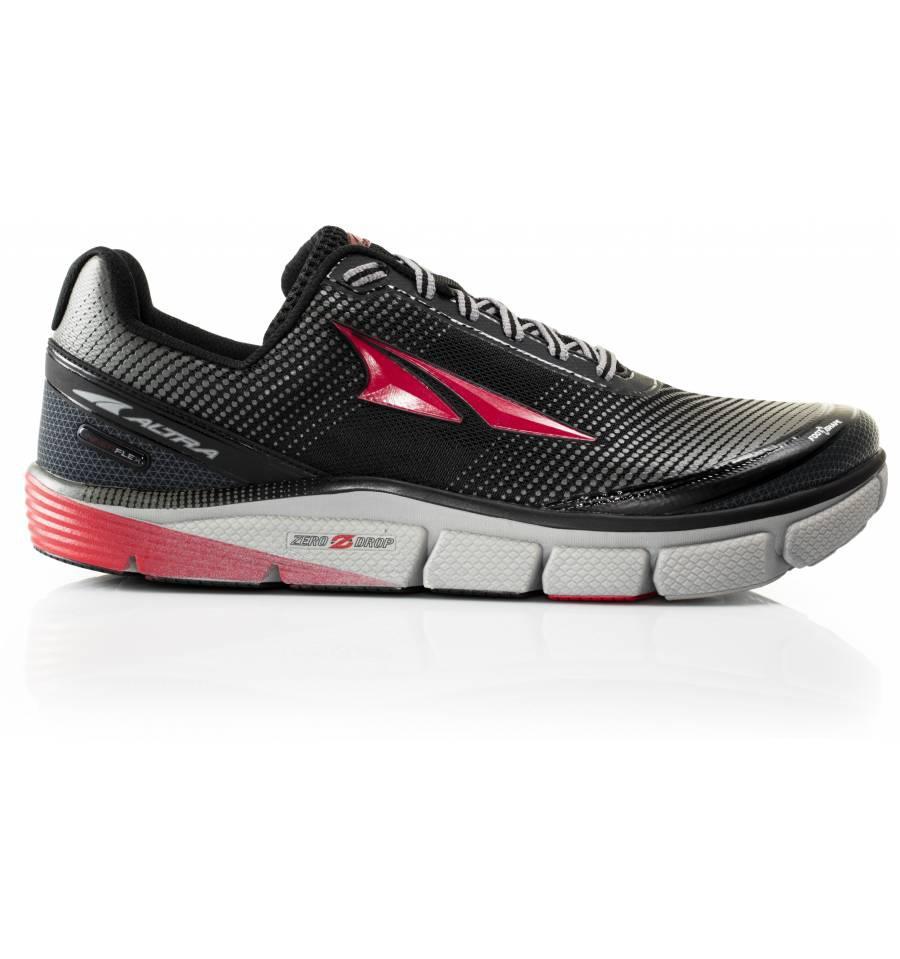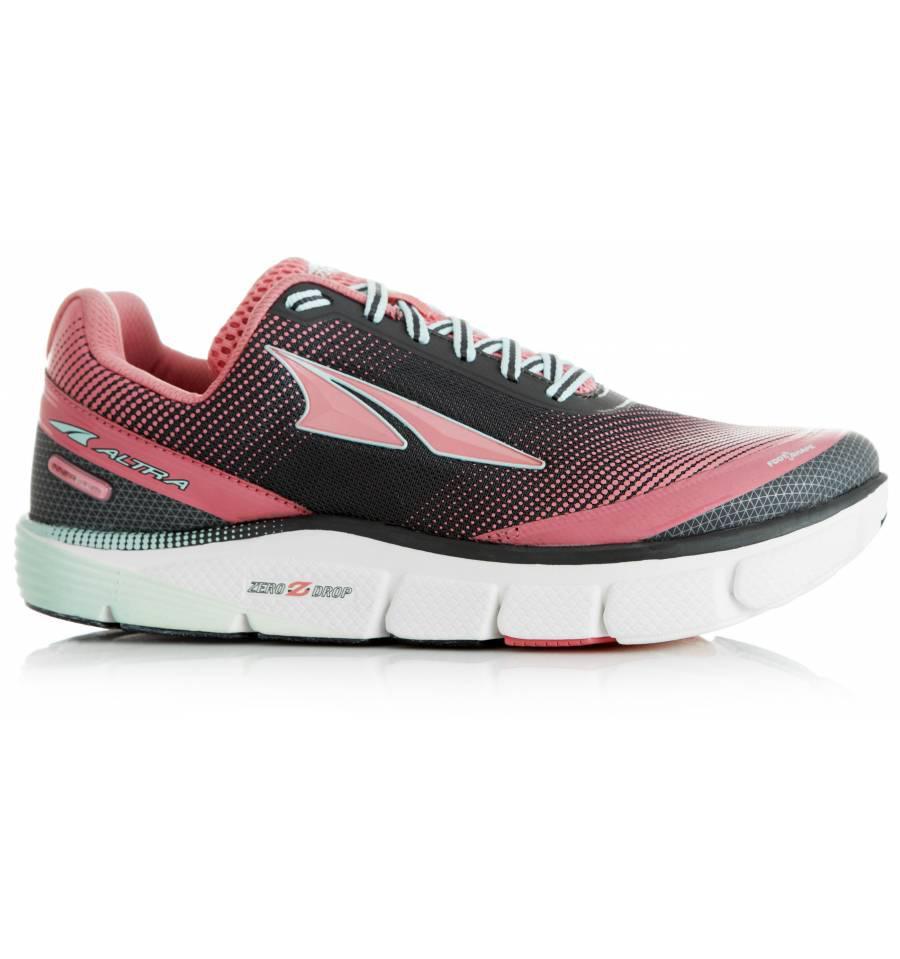The first image is the image on the left, the second image is the image on the right. Considering the images on both sides, is "There is exactly two sports tennis shoes in the left image." valid? Answer yes or no. No. 